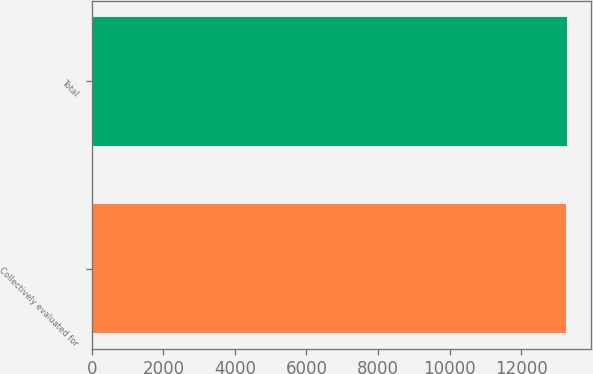<chart> <loc_0><loc_0><loc_500><loc_500><bar_chart><fcel>Collectively evaluated for<fcel>Total<nl><fcel>13251<fcel>13277<nl></chart> 